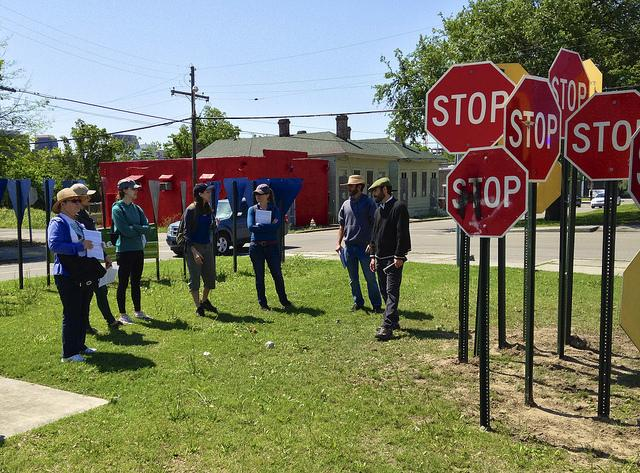Who created the works seen here? Please explain your reasoning. artist. It is an artist because so many stop signs would not be on the road this close together 